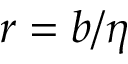<formula> <loc_0><loc_0><loc_500><loc_500>r = b / \eta</formula> 